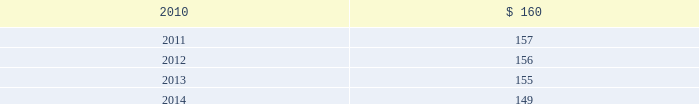Blackrock n 96 n notes in april 2009 , the company acquired $ 2 million of finite- lived management contracts with a five-year estimated useful life associated with the acquisition of the r3 capital partners funds .
In december 2009 , in conjunction with the bgi trans- action , the company acquired $ 163 million of finite- lived management contracts with a weighted-average estimated useful life of approximately 10 years .
Estimated amortization expense for finite-lived intangible assets for each of the five succeeding years is as follows : ( dollar amounts in millions ) .
Indefinite-lived acquired management contracts on september 29 , 2006 , in conjunction with the mlim transaction , the company acquired indefinite-lived man- agement contracts valued at $ 4477 million consisting of $ 4271 million for all retail mutual funds and $ 206 million for alternative investment products .
On october 1 , 2007 , in conjunction with the quellos transaction , the company acquired $ 631 million in indefinite-lived management contracts associated with alternative investment products .
On october 1 , 2007 , the company purchased the remain- ing 20% ( 20 % ) of an investment manager of a fund of hedge funds .
In conjunction with this transaction , the company recorded $ 8 million in additional indefinite-lived management contracts associated with alternative investment products .
On december 1 , 2009 , in conjunction with the bgi transaction , the company acquired $ 9785 million in indefinite-lived management contracts valued consisting primarily for exchange traded funds and common and collective trusts .
Indefinite-lived acquired trade names/trademarks on december 1 , 2009 , in conjunction with the bgi transaction , the company acquired trade names/ trademarks primarily related to ishares valued at $ 1402.5 million .
The fair value was determined using a royalty rate based primarily on normalized marketing and promotion expenditures to develop and support the brands globally .
13 .
Borrowings short-term borrowings 2007 facility in august 2007 , the company entered into a five-year $ 2.5 billion unsecured revolving credit facility ( the 201c2007 facility 201d ) , which permits the company to request an additional $ 500 million of borrowing capacity , subject to lender credit approval , up to a maximum of $ 3.0 billion .
The 2007 facility requires the company not to exceed a maximum leverage ratio ( ratio of net debt to earnings before interest , taxes , depreciation and amortiza- tion , where net debt equals total debt less domestic unrestricted cash ) of 3 to 1 , which was satisfied with a ratio of less than 1 to 1 at december 31 , 2009 .
The 2007 facility provides back-up liquidity , funds ongoing working capital for general corporate purposes and funds various investment opportunities .
At december 31 , 2009 , the company had $ 200 million outstanding under the 2007 facility with an interest rate of 0.44% ( 0.44 % ) and a maturity date during february 2010 .
During february 2010 , the company rolled over $ 100 million in borrowings with an interest rate of 0.43% ( 0.43 % ) and a maturity date in may 2010 .
Lehman commercial paper inc .
Has a $ 140 million participation under the 2007 facility ; however blackrock does not expect that lehman commercial paper inc .
Will honor its commitment to fund additional amounts .
Bank of america , a related party , has a $ 140 million participation under the 2007 facility .
In december 2007 , in order to support two enhanced cash funds that blackrock manages , blackrock elected to procure two letters of credit under the existing 2007 facility in an aggregate amount of $ 100 million .
In decem- ber 2008 , the letters of credit were terminated .
Commercial paper program on october 14 , 2009 , blackrock established a com- mercial paper program ( the 201ccp program 201d ) under which the company may issue unsecured commercial paper notes ( the 201ccp notes 201d ) on a private placement basis up to a maximum aggregate amount outstanding at any time of $ 3 billion .
The proceeds of the commercial paper issuances were used for the financing of a portion of the bgi transaction .
Subsidiaries of bank of america and barclays , as well as other third parties , act as dealers under the cp program .
The cp program is supported by the 2007 facility .
The company began issuance of cp notes under the cp program on november 4 , 2009 .
As of december 31 , 2009 , blackrock had approximately $ 2 billion of out- standing cp notes with a weighted average interest rate of 0.20% ( 0.20 % ) and a weighted average maturity of 23 days .
Since december 31 , 2009 , the company repaid approxi- mately $ 1.4 billion of cp notes with proceeds from the long-term notes issued in december 2009 .
As of march 5 , 2010 , blackrock had $ 596 million of outstanding cp notes with a weighted average interest rate of 0.18% ( 0.18 % ) and a weighted average maturity of 38 days .
Japan commitment-line in june 2008 , blackrock japan co. , ltd. , a wholly owned subsidiary of the company , entered into a five billion japanese yen commitment-line agreement with a bank- ing institution ( the 201cjapan commitment-line 201d ) .
The term of the japan commitment-line was one year and interest accrued at the applicable japanese short-term prime rate .
In june 2009 , blackrock japan co. , ltd .
Renewed the japan commitment-line for a term of one year .
The japan commitment-line is intended to provide liquid- ity and flexibility for operating requirements in japan .
At december 31 , 2009 , the company had no borrowings outstanding on the japan commitment-line .
Convertible debentures in february 2005 , the company issued $ 250 million aggregate principal amount of convertible debentures ( the 201cdebentures 201d ) , due in 2035 and bearing interest at a rate of 2.625% ( 2.625 % ) per annum .
Interest is payable semi- annually in arrears on february 15 and august 15 of each year , and commenced august 15 , 2005 .
Prior to february 15 , 2009 , the debentures could have been convertible at the option of the holder at a decem- ber 31 , 2008 conversion rate of 9.9639 shares of common stock per one dollar principal amount of debentures under certain circumstances .
The debentures would have been convertible into cash and , in some situations as described below , additional shares of the company 2019s common stock , if during the five business day period after any five consecutive trading day period the trading price per debenture for each day of such period is less than 103% ( 103 % ) of the product of the last reported sales price of blackrock 2019s common stock and the conversion rate of the debentures on each such day or upon the occurrence of certain other corporate events , such as a distribution to the holders of blackrock common stock of certain rights , assets or debt securities , if the company becomes party to a merger , consolidation or transfer of all or substantially all of its assets or a change of control of the company .
On february 15 , 2009 , the debentures became convertible into cash at any time prior to maturity at the option of the holder and , in some situations as described below , additional shares of the company 2019s common stock at the current conversion rate .
At the time the debentures are tendered for conver- sion , for each one dollar principal amount of debentures converted , a holder shall be entitled to receive cash and shares of blackrock common stock , if any , the aggregate value of which ( the 201cconversion value 201d ) will be deter- mined by multiplying the applicable conversion rate by the average of the daily volume weighted average price of blackrock common stock for each of the ten consecutive trading days beginning on the second trading day imme- diately following the day the debentures are tendered for conversion ( the 201cten-day weighted average price 201d ) .
The company will deliver the conversion value to holders as follows : ( 1 ) an amount in cash ( the 201cprincipal return 201d ) equal to the lesser of ( a ) the aggregate conversion value of the debentures to be converted and ( b ) the aggregate principal amount of the debentures to be converted , and ( 2 ) if the aggregate conversion value of the debentures to be converted is greater than the principal return , an amount in shares ( the 201cnet shares 201d ) , determined as set forth below , equal to such aggregate conversion value less the principal return ( the 201cnet share amount 201d ) .
The number of net shares to be paid will be determined by dividing the net share amount by the ten-day weighted average price .
In lieu of delivering fractional shares , the company will deliver cash based on the ten-day weighted average price .
The conversion rate for the debentures is subject to adjustments upon the occurrence of certain corporate events , such as a change of control of the company , 193253ti_txt.indd 96 4/2/10 1:18 pm .
What is the 2010 estimated amortization expense for finite-lived intangible assets as a percentage of the unsecured revolving credit facility? 
Computations: (2.5 / 1000)
Answer: 0.0025. 